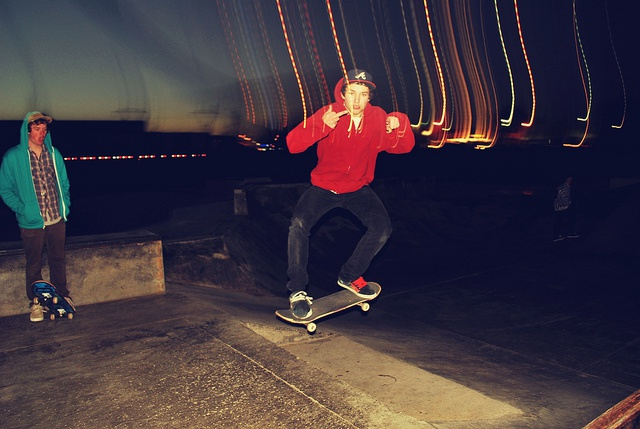Describe the objects in this image and their specific colors. I can see people in darkblue, black, brown, and khaki tones, people in darkblue, black, teal, gray, and brown tones, skateboard in darkblue, gray, khaki, and black tones, and skateboard in darkblue, black, navy, teal, and brown tones in this image. 